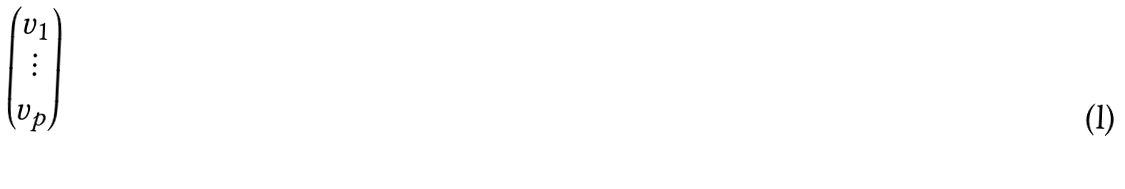<formula> <loc_0><loc_0><loc_500><loc_500>\begin{pmatrix} v _ { 1 } \\ \vdots \\ v _ { p } \end{pmatrix}</formula> 